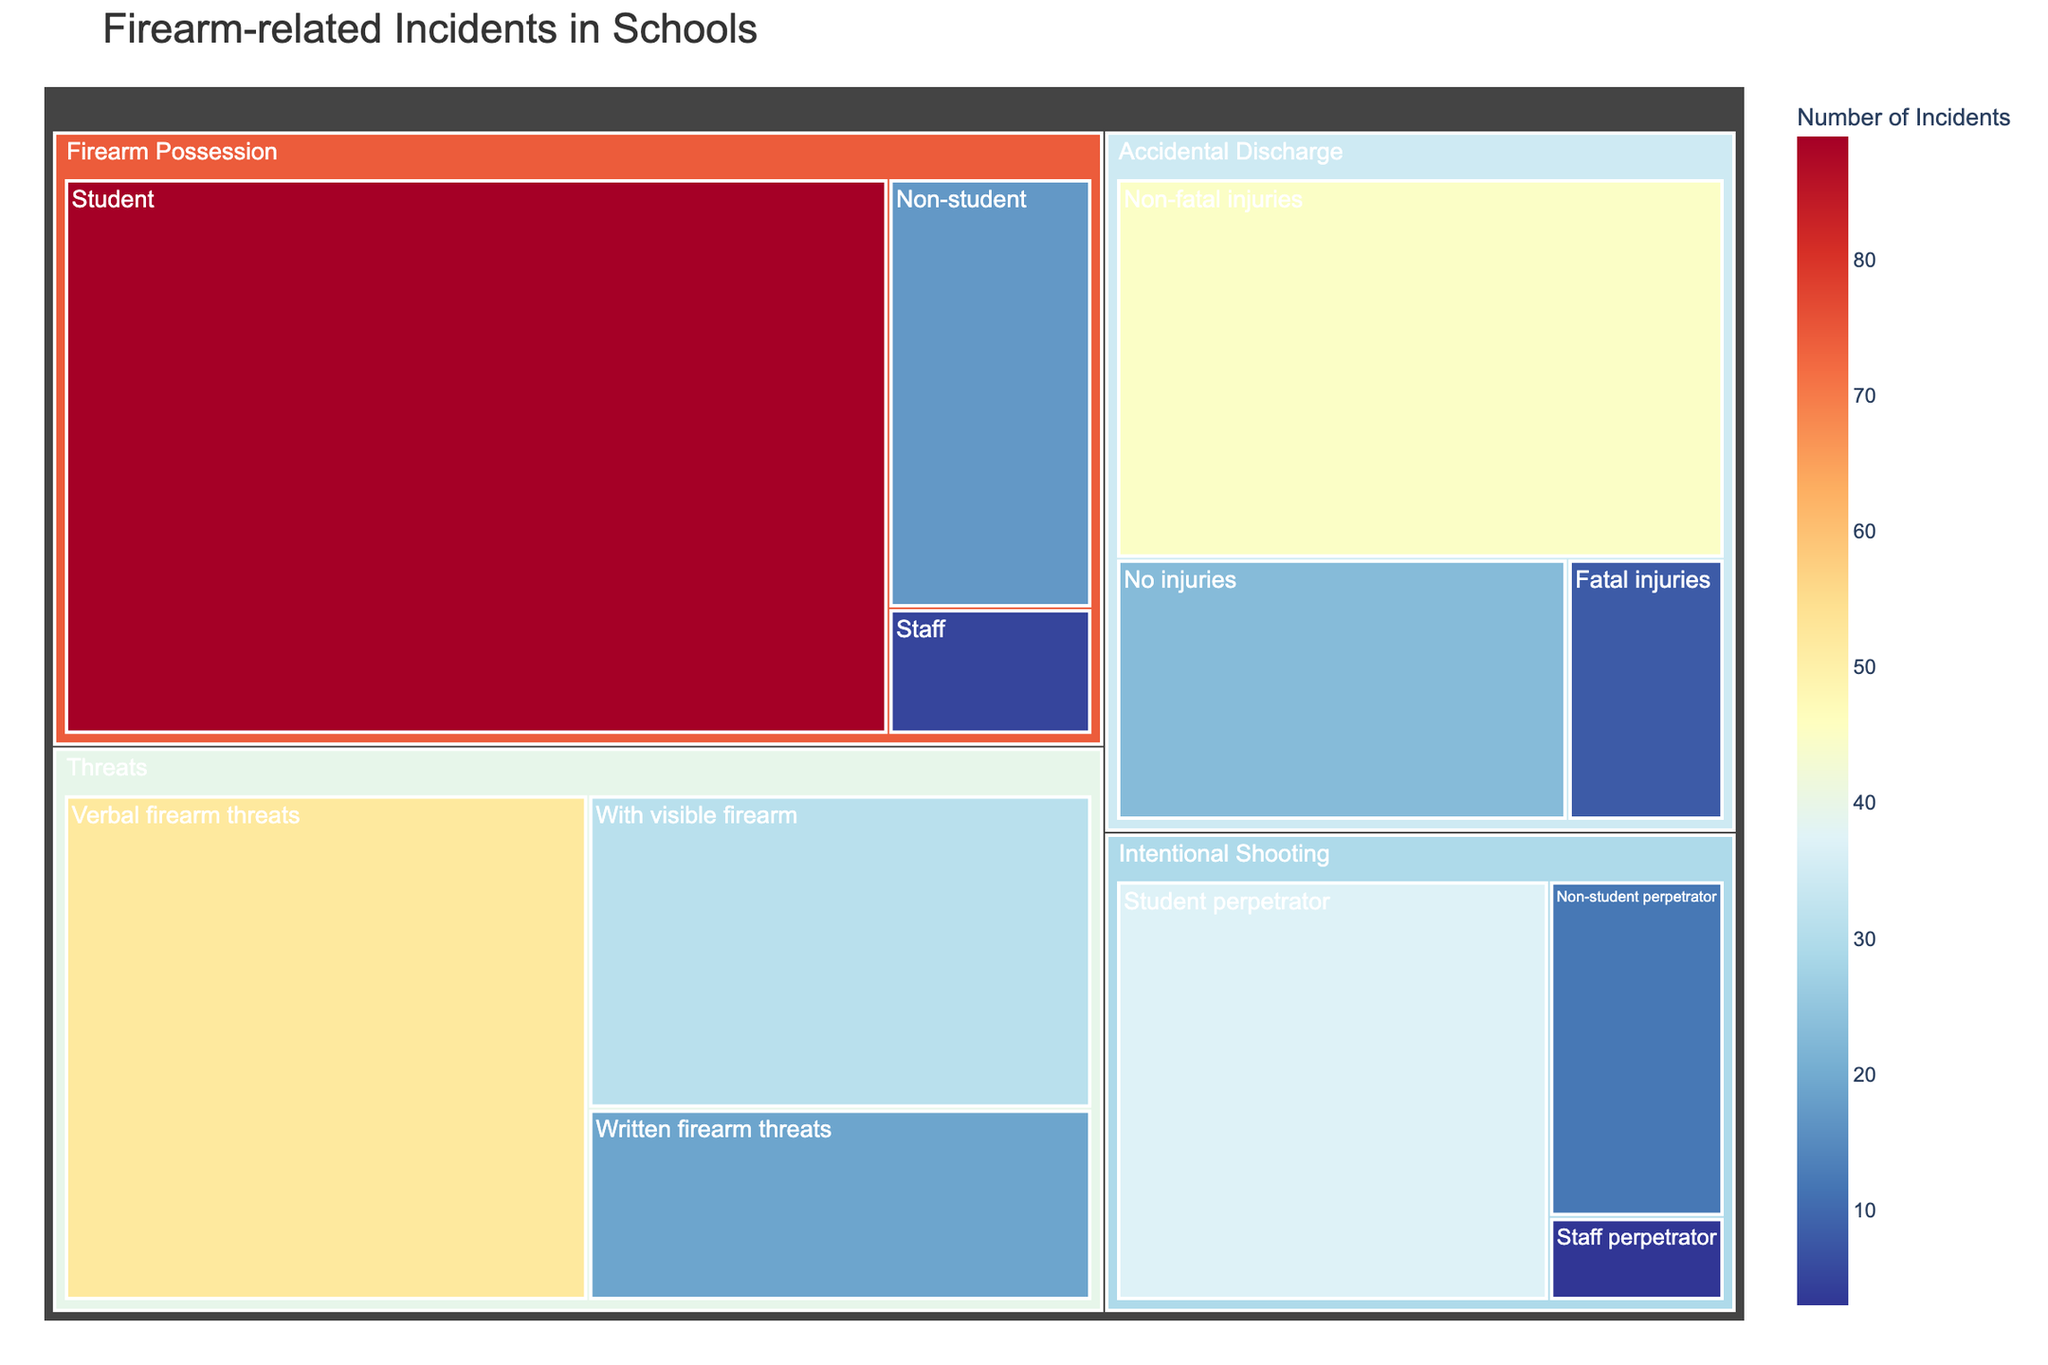What's the title of the figure? The title of a figure is usually prominently displayed at the top part of the visual. In this case, it is "Firearm-related Incidents in Schools."
Answer: Firearm-related Incidents in Schools Which category has the highest number of incidents overall? To identify this, sum the incidents for each main category: Accidental Discharge (45+8+23=76), Intentional Shooting (37+12+3=52), Firearm Possession (89+17+5=111), Threats (31+52+19=102). The highest is Firearm Possession.
Answer: Firearm Possession What is the total number of incidents in the Accidental Discharge category? Add the incidents in all subcategories of Accidental Discharge: Non-fatal injuries (45), Fatal injuries (8), and No injuries (23). The total is 45 + 8 + 23 = 76.
Answer: 76 Which subcategory of Intentional Shooting has the fewest incidents? Review the subcategories of Intentional Shooting: Student perpetrator (37), Non-student perpetrator (12), and Staff perpetrator (3). The fewest is Staff perpetrator.
Answer: Staff perpetrator What's the difference in the number of incidents between the Threats category and the Firearm Possession category? First, total the incidents in each category: Threats (31+52+19=102), Firearm Possession (89+17+5=111). The difference is 111 - 102 = 9.
Answer: 9 Among Threats, which subcategory has the most incidents? Examine the subcategories of Threats: With visible firearm (31), Verbal firearm threats (52), and Written firearm threats (19). The most is Verbal firearm threats.
Answer: Verbal firearm threats How many more incidents does the category with the most incidents have compared to the one with the fewest? The category with the most incidents is Firearm Possession (111), and the one with the fewest is Intentional Shooting (52). The difference is 111 - 52 = 59.
Answer: 59 What percentage of the total incidents does Firearm Possession represent? Calculate the total incidents: Accidental Discharge (76), Intentional Shooting (52), Firearm Possession (111), Threats (102). The grand total is 76+52+111+102=341. Percentage = (111/341) * 100 ≈ 32.55%.
Answer: 32.55% Which category of incidents related to guns in schools has the broadest range in number of incidents across its subcategories? Calculate the difference between the highest and lowest subcategory incidents within each category: Accidental Discharge (45-8=37), Intentional Shooting (37-3=34), Firearm Possession (89-5=84), Threats (52-19=33). The broadest range is in Firearm Possession.
Answer: Firearm Possession 